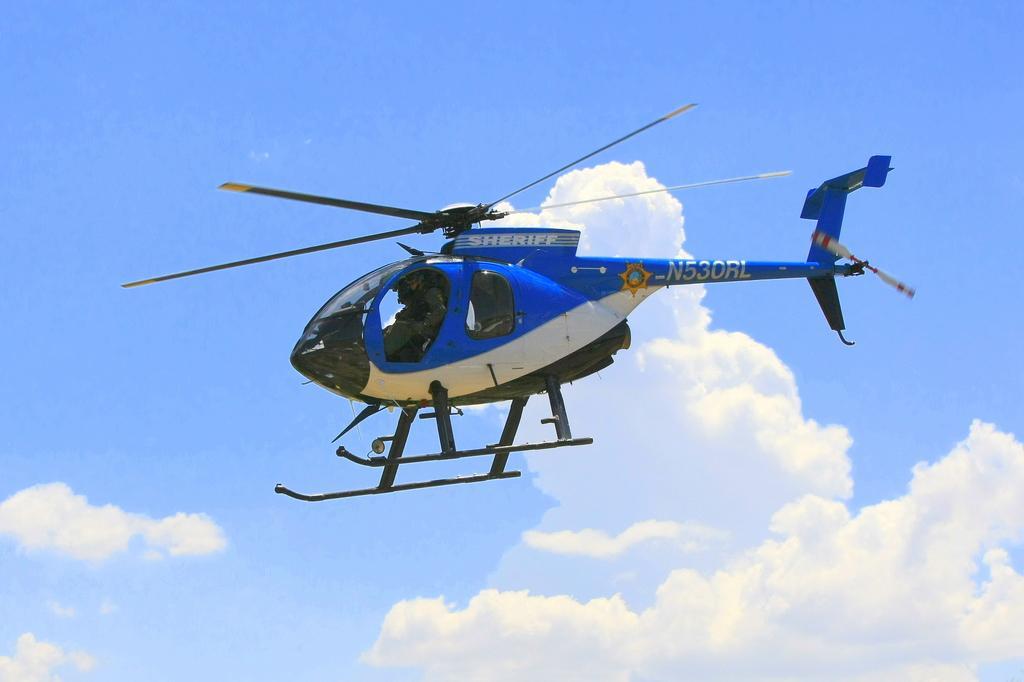Describe this image in one or two sentences. In this picture I can see a helicopter flying, and in the background there is the sky. 